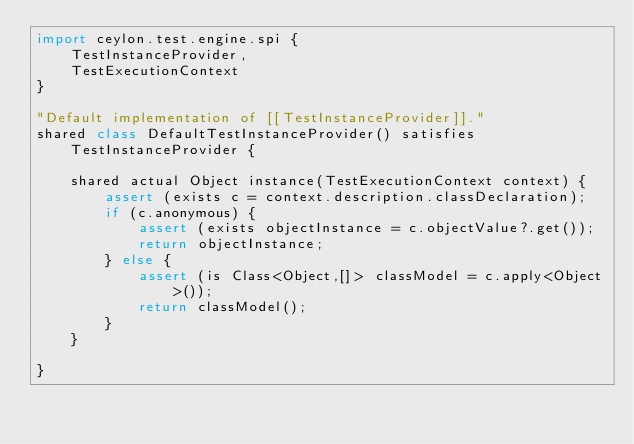<code> <loc_0><loc_0><loc_500><loc_500><_Ceylon_>import ceylon.test.engine.spi {
    TestInstanceProvider,
    TestExecutionContext
}

"Default implementation of [[TestInstanceProvider]]."
shared class DefaultTestInstanceProvider() satisfies TestInstanceProvider {
    
    shared actual Object instance(TestExecutionContext context) {
        assert (exists c = context.description.classDeclaration);
        if (c.anonymous) {
            assert (exists objectInstance = c.objectValue?.get());
            return objectInstance;
        } else {
            assert (is Class<Object,[]> classModel = c.apply<Object>());
            return classModel();
        }
    }
    
}
</code> 